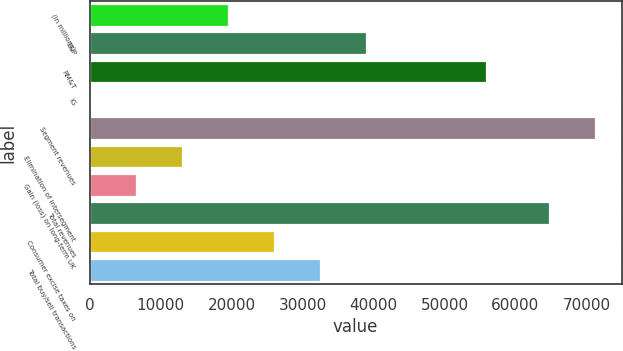<chart> <loc_0><loc_0><loc_500><loc_500><bar_chart><fcel>(In millions)<fcel>E&P<fcel>RM&T<fcel>IG<fcel>Segment revenues<fcel>Elimination of intersegment<fcel>Gain (loss) on long-term UK<fcel>Total revenues<fcel>Consumer excise taxes on<fcel>Total buy/sell transactions<nl><fcel>19664.3<fcel>39149.6<fcel>55941<fcel>179<fcel>71391.1<fcel>13169.2<fcel>6674.1<fcel>64896<fcel>26159.4<fcel>32654.5<nl></chart> 